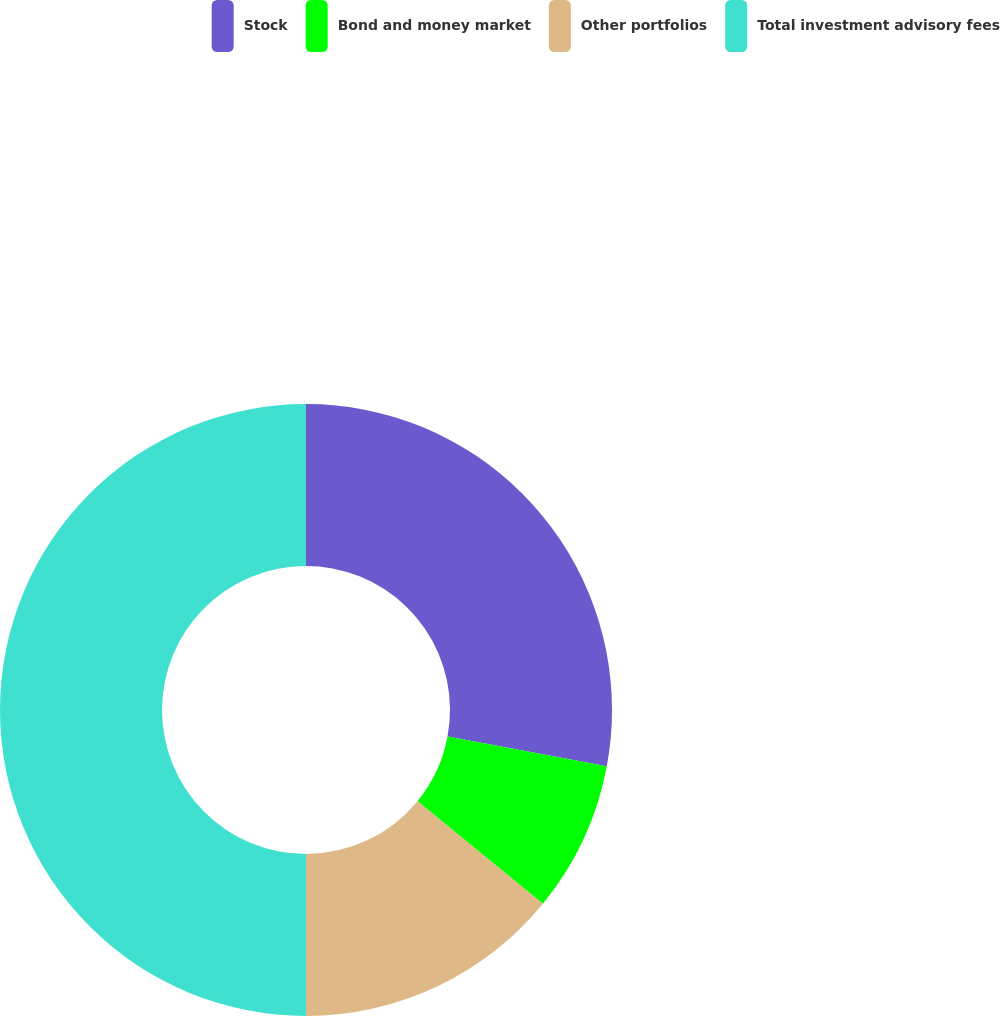<chart> <loc_0><loc_0><loc_500><loc_500><pie_chart><fcel>Stock<fcel>Bond and money market<fcel>Other portfolios<fcel>Total investment advisory fees<nl><fcel>27.94%<fcel>7.97%<fcel>14.09%<fcel>50.0%<nl></chart> 